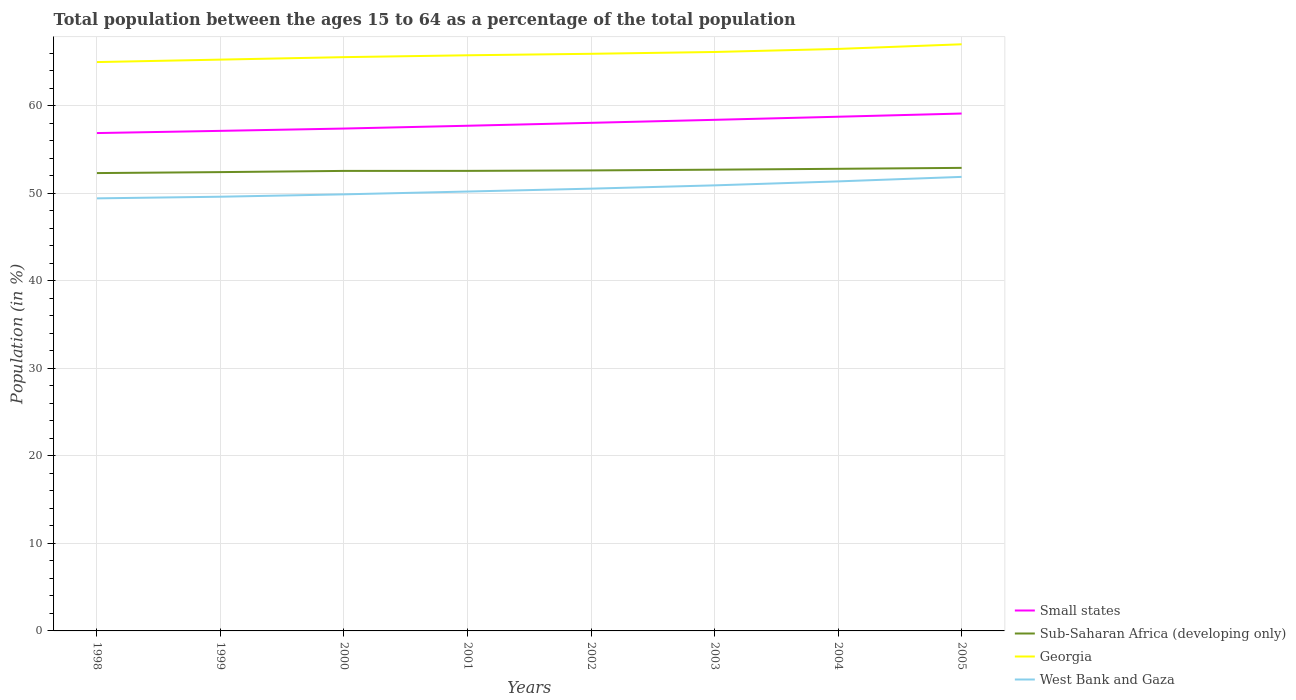Does the line corresponding to West Bank and Gaza intersect with the line corresponding to Small states?
Offer a terse response. No. Is the number of lines equal to the number of legend labels?
Keep it short and to the point. Yes. Across all years, what is the maximum percentage of the population ages 15 to 64 in Sub-Saharan Africa (developing only)?
Offer a very short reply. 52.33. In which year was the percentage of the population ages 15 to 64 in West Bank and Gaza maximum?
Offer a terse response. 1998. What is the total percentage of the population ages 15 to 64 in Georgia in the graph?
Ensure brevity in your answer.  -0.53. What is the difference between the highest and the second highest percentage of the population ages 15 to 64 in West Bank and Gaza?
Give a very brief answer. 2.46. What is the difference between the highest and the lowest percentage of the population ages 15 to 64 in Small states?
Provide a short and direct response. 4. Is the percentage of the population ages 15 to 64 in Georgia strictly greater than the percentage of the population ages 15 to 64 in Small states over the years?
Your response must be concise. No. What is the difference between two consecutive major ticks on the Y-axis?
Provide a succinct answer. 10. Are the values on the major ticks of Y-axis written in scientific E-notation?
Offer a very short reply. No. Does the graph contain any zero values?
Offer a terse response. No. Where does the legend appear in the graph?
Give a very brief answer. Bottom right. How are the legend labels stacked?
Your answer should be compact. Vertical. What is the title of the graph?
Keep it short and to the point. Total population between the ages 15 to 64 as a percentage of the total population. Does "Paraguay" appear as one of the legend labels in the graph?
Provide a succinct answer. No. What is the Population (in %) in Small states in 1998?
Provide a succinct answer. 56.9. What is the Population (in %) in Sub-Saharan Africa (developing only) in 1998?
Your answer should be very brief. 52.33. What is the Population (in %) in Georgia in 1998?
Make the answer very short. 65.01. What is the Population (in %) of West Bank and Gaza in 1998?
Your response must be concise. 49.44. What is the Population (in %) of Small states in 1999?
Keep it short and to the point. 57.15. What is the Population (in %) in Sub-Saharan Africa (developing only) in 1999?
Your answer should be very brief. 52.44. What is the Population (in %) of Georgia in 1999?
Your answer should be very brief. 65.3. What is the Population (in %) of West Bank and Gaza in 1999?
Provide a short and direct response. 49.63. What is the Population (in %) of Small states in 2000?
Give a very brief answer. 57.42. What is the Population (in %) of Sub-Saharan Africa (developing only) in 2000?
Your answer should be compact. 52.58. What is the Population (in %) in Georgia in 2000?
Offer a very short reply. 65.58. What is the Population (in %) of West Bank and Gaza in 2000?
Offer a very short reply. 49.9. What is the Population (in %) in Small states in 2001?
Your answer should be very brief. 57.74. What is the Population (in %) of Sub-Saharan Africa (developing only) in 2001?
Your answer should be very brief. 52.58. What is the Population (in %) of Georgia in 2001?
Keep it short and to the point. 65.79. What is the Population (in %) in West Bank and Gaza in 2001?
Provide a short and direct response. 50.22. What is the Population (in %) of Small states in 2002?
Your answer should be compact. 58.07. What is the Population (in %) of Sub-Saharan Africa (developing only) in 2002?
Offer a very short reply. 52.63. What is the Population (in %) of Georgia in 2002?
Make the answer very short. 65.96. What is the Population (in %) of West Bank and Gaza in 2002?
Ensure brevity in your answer.  50.55. What is the Population (in %) of Small states in 2003?
Provide a short and direct response. 58.42. What is the Population (in %) of Sub-Saharan Africa (developing only) in 2003?
Your answer should be compact. 52.72. What is the Population (in %) in Georgia in 2003?
Your answer should be compact. 66.17. What is the Population (in %) of West Bank and Gaza in 2003?
Keep it short and to the point. 50.93. What is the Population (in %) of Small states in 2004?
Provide a succinct answer. 58.77. What is the Population (in %) of Sub-Saharan Africa (developing only) in 2004?
Give a very brief answer. 52.82. What is the Population (in %) of Georgia in 2004?
Offer a terse response. 66.52. What is the Population (in %) of West Bank and Gaza in 2004?
Your answer should be very brief. 51.38. What is the Population (in %) in Small states in 2005?
Keep it short and to the point. 59.13. What is the Population (in %) in Sub-Saharan Africa (developing only) in 2005?
Provide a succinct answer. 52.92. What is the Population (in %) in Georgia in 2005?
Your answer should be compact. 67.05. What is the Population (in %) of West Bank and Gaza in 2005?
Provide a succinct answer. 51.89. Across all years, what is the maximum Population (in %) of Small states?
Ensure brevity in your answer.  59.13. Across all years, what is the maximum Population (in %) of Sub-Saharan Africa (developing only)?
Your answer should be compact. 52.92. Across all years, what is the maximum Population (in %) of Georgia?
Offer a very short reply. 67.05. Across all years, what is the maximum Population (in %) in West Bank and Gaza?
Your answer should be very brief. 51.89. Across all years, what is the minimum Population (in %) in Small states?
Ensure brevity in your answer.  56.9. Across all years, what is the minimum Population (in %) in Sub-Saharan Africa (developing only)?
Provide a succinct answer. 52.33. Across all years, what is the minimum Population (in %) of Georgia?
Offer a terse response. 65.01. Across all years, what is the minimum Population (in %) in West Bank and Gaza?
Your response must be concise. 49.44. What is the total Population (in %) in Small states in the graph?
Make the answer very short. 463.6. What is the total Population (in %) of Sub-Saharan Africa (developing only) in the graph?
Your response must be concise. 421.02. What is the total Population (in %) of Georgia in the graph?
Provide a short and direct response. 527.38. What is the total Population (in %) in West Bank and Gaza in the graph?
Give a very brief answer. 403.93. What is the difference between the Population (in %) of Small states in 1998 and that in 1999?
Give a very brief answer. -0.25. What is the difference between the Population (in %) of Sub-Saharan Africa (developing only) in 1998 and that in 1999?
Make the answer very short. -0.11. What is the difference between the Population (in %) of Georgia in 1998 and that in 1999?
Your answer should be compact. -0.28. What is the difference between the Population (in %) of West Bank and Gaza in 1998 and that in 1999?
Offer a terse response. -0.19. What is the difference between the Population (in %) of Small states in 1998 and that in 2000?
Ensure brevity in your answer.  -0.52. What is the difference between the Population (in %) of Sub-Saharan Africa (developing only) in 1998 and that in 2000?
Your answer should be very brief. -0.25. What is the difference between the Population (in %) in Georgia in 1998 and that in 2000?
Provide a succinct answer. -0.57. What is the difference between the Population (in %) in West Bank and Gaza in 1998 and that in 2000?
Give a very brief answer. -0.46. What is the difference between the Population (in %) of Small states in 1998 and that in 2001?
Offer a terse response. -0.84. What is the difference between the Population (in %) of Sub-Saharan Africa (developing only) in 1998 and that in 2001?
Make the answer very short. -0.25. What is the difference between the Population (in %) in Georgia in 1998 and that in 2001?
Give a very brief answer. -0.78. What is the difference between the Population (in %) of West Bank and Gaza in 1998 and that in 2001?
Provide a succinct answer. -0.78. What is the difference between the Population (in %) in Small states in 1998 and that in 2002?
Ensure brevity in your answer.  -1.17. What is the difference between the Population (in %) in Sub-Saharan Africa (developing only) in 1998 and that in 2002?
Provide a short and direct response. -0.3. What is the difference between the Population (in %) in Georgia in 1998 and that in 2002?
Your response must be concise. -0.95. What is the difference between the Population (in %) of West Bank and Gaza in 1998 and that in 2002?
Give a very brief answer. -1.11. What is the difference between the Population (in %) in Small states in 1998 and that in 2003?
Make the answer very short. -1.51. What is the difference between the Population (in %) in Sub-Saharan Africa (developing only) in 1998 and that in 2003?
Your answer should be compact. -0.39. What is the difference between the Population (in %) in Georgia in 1998 and that in 2003?
Your answer should be compact. -1.15. What is the difference between the Population (in %) in West Bank and Gaza in 1998 and that in 2003?
Your answer should be compact. -1.49. What is the difference between the Population (in %) of Small states in 1998 and that in 2004?
Provide a succinct answer. -1.87. What is the difference between the Population (in %) of Sub-Saharan Africa (developing only) in 1998 and that in 2004?
Keep it short and to the point. -0.49. What is the difference between the Population (in %) of Georgia in 1998 and that in 2004?
Your answer should be compact. -1.5. What is the difference between the Population (in %) of West Bank and Gaza in 1998 and that in 2004?
Keep it short and to the point. -1.94. What is the difference between the Population (in %) of Small states in 1998 and that in 2005?
Your response must be concise. -2.23. What is the difference between the Population (in %) of Sub-Saharan Africa (developing only) in 1998 and that in 2005?
Provide a short and direct response. -0.59. What is the difference between the Population (in %) of Georgia in 1998 and that in 2005?
Your response must be concise. -2.04. What is the difference between the Population (in %) in West Bank and Gaza in 1998 and that in 2005?
Your response must be concise. -2.46. What is the difference between the Population (in %) of Small states in 1999 and that in 2000?
Offer a terse response. -0.26. What is the difference between the Population (in %) of Sub-Saharan Africa (developing only) in 1999 and that in 2000?
Your answer should be compact. -0.14. What is the difference between the Population (in %) of Georgia in 1999 and that in 2000?
Provide a short and direct response. -0.28. What is the difference between the Population (in %) in West Bank and Gaza in 1999 and that in 2000?
Offer a very short reply. -0.27. What is the difference between the Population (in %) of Small states in 1999 and that in 2001?
Offer a very short reply. -0.59. What is the difference between the Population (in %) in Sub-Saharan Africa (developing only) in 1999 and that in 2001?
Make the answer very short. -0.14. What is the difference between the Population (in %) of Georgia in 1999 and that in 2001?
Your answer should be very brief. -0.49. What is the difference between the Population (in %) in West Bank and Gaza in 1999 and that in 2001?
Offer a very short reply. -0.59. What is the difference between the Population (in %) in Small states in 1999 and that in 2002?
Your answer should be compact. -0.92. What is the difference between the Population (in %) in Sub-Saharan Africa (developing only) in 1999 and that in 2002?
Offer a terse response. -0.19. What is the difference between the Population (in %) in Georgia in 1999 and that in 2002?
Keep it short and to the point. -0.66. What is the difference between the Population (in %) of West Bank and Gaza in 1999 and that in 2002?
Keep it short and to the point. -0.92. What is the difference between the Population (in %) of Small states in 1999 and that in 2003?
Keep it short and to the point. -1.26. What is the difference between the Population (in %) in Sub-Saharan Africa (developing only) in 1999 and that in 2003?
Your answer should be very brief. -0.28. What is the difference between the Population (in %) of Georgia in 1999 and that in 2003?
Give a very brief answer. -0.87. What is the difference between the Population (in %) of West Bank and Gaza in 1999 and that in 2003?
Keep it short and to the point. -1.3. What is the difference between the Population (in %) in Small states in 1999 and that in 2004?
Your response must be concise. -1.61. What is the difference between the Population (in %) of Sub-Saharan Africa (developing only) in 1999 and that in 2004?
Your response must be concise. -0.38. What is the difference between the Population (in %) in Georgia in 1999 and that in 2004?
Your answer should be very brief. -1.22. What is the difference between the Population (in %) of West Bank and Gaza in 1999 and that in 2004?
Give a very brief answer. -1.75. What is the difference between the Population (in %) of Small states in 1999 and that in 2005?
Make the answer very short. -1.98. What is the difference between the Population (in %) of Sub-Saharan Africa (developing only) in 1999 and that in 2005?
Provide a succinct answer. -0.48. What is the difference between the Population (in %) in Georgia in 1999 and that in 2005?
Keep it short and to the point. -1.75. What is the difference between the Population (in %) in West Bank and Gaza in 1999 and that in 2005?
Offer a terse response. -2.27. What is the difference between the Population (in %) of Small states in 2000 and that in 2001?
Keep it short and to the point. -0.32. What is the difference between the Population (in %) in Sub-Saharan Africa (developing only) in 2000 and that in 2001?
Provide a short and direct response. -0. What is the difference between the Population (in %) of Georgia in 2000 and that in 2001?
Offer a terse response. -0.21. What is the difference between the Population (in %) in West Bank and Gaza in 2000 and that in 2001?
Provide a short and direct response. -0.32. What is the difference between the Population (in %) in Small states in 2000 and that in 2002?
Provide a short and direct response. -0.65. What is the difference between the Population (in %) in Sub-Saharan Africa (developing only) in 2000 and that in 2002?
Your response must be concise. -0.06. What is the difference between the Population (in %) of Georgia in 2000 and that in 2002?
Your answer should be compact. -0.38. What is the difference between the Population (in %) in West Bank and Gaza in 2000 and that in 2002?
Give a very brief answer. -0.65. What is the difference between the Population (in %) in Small states in 2000 and that in 2003?
Your answer should be compact. -1. What is the difference between the Population (in %) in Sub-Saharan Africa (developing only) in 2000 and that in 2003?
Offer a very short reply. -0.14. What is the difference between the Population (in %) in Georgia in 2000 and that in 2003?
Your answer should be very brief. -0.59. What is the difference between the Population (in %) in West Bank and Gaza in 2000 and that in 2003?
Offer a very short reply. -1.03. What is the difference between the Population (in %) in Small states in 2000 and that in 2004?
Your answer should be compact. -1.35. What is the difference between the Population (in %) in Sub-Saharan Africa (developing only) in 2000 and that in 2004?
Your answer should be very brief. -0.24. What is the difference between the Population (in %) of Georgia in 2000 and that in 2004?
Offer a terse response. -0.94. What is the difference between the Population (in %) in West Bank and Gaza in 2000 and that in 2004?
Offer a very short reply. -1.48. What is the difference between the Population (in %) of Small states in 2000 and that in 2005?
Provide a short and direct response. -1.72. What is the difference between the Population (in %) of Sub-Saharan Africa (developing only) in 2000 and that in 2005?
Ensure brevity in your answer.  -0.35. What is the difference between the Population (in %) in Georgia in 2000 and that in 2005?
Give a very brief answer. -1.47. What is the difference between the Population (in %) in West Bank and Gaza in 2000 and that in 2005?
Offer a terse response. -2. What is the difference between the Population (in %) in Small states in 2001 and that in 2002?
Your answer should be compact. -0.33. What is the difference between the Population (in %) of Sub-Saharan Africa (developing only) in 2001 and that in 2002?
Your answer should be compact. -0.05. What is the difference between the Population (in %) of Georgia in 2001 and that in 2002?
Offer a very short reply. -0.17. What is the difference between the Population (in %) of West Bank and Gaza in 2001 and that in 2002?
Make the answer very short. -0.33. What is the difference between the Population (in %) of Small states in 2001 and that in 2003?
Offer a very short reply. -0.68. What is the difference between the Population (in %) of Sub-Saharan Africa (developing only) in 2001 and that in 2003?
Your response must be concise. -0.14. What is the difference between the Population (in %) in Georgia in 2001 and that in 2003?
Offer a very short reply. -0.38. What is the difference between the Population (in %) of West Bank and Gaza in 2001 and that in 2003?
Keep it short and to the point. -0.71. What is the difference between the Population (in %) of Small states in 2001 and that in 2004?
Provide a succinct answer. -1.03. What is the difference between the Population (in %) of Sub-Saharan Africa (developing only) in 2001 and that in 2004?
Offer a terse response. -0.24. What is the difference between the Population (in %) in Georgia in 2001 and that in 2004?
Provide a short and direct response. -0.73. What is the difference between the Population (in %) in West Bank and Gaza in 2001 and that in 2004?
Provide a short and direct response. -1.16. What is the difference between the Population (in %) of Small states in 2001 and that in 2005?
Ensure brevity in your answer.  -1.4. What is the difference between the Population (in %) of Sub-Saharan Africa (developing only) in 2001 and that in 2005?
Keep it short and to the point. -0.34. What is the difference between the Population (in %) in Georgia in 2001 and that in 2005?
Keep it short and to the point. -1.26. What is the difference between the Population (in %) of West Bank and Gaza in 2001 and that in 2005?
Offer a very short reply. -1.67. What is the difference between the Population (in %) in Small states in 2002 and that in 2003?
Give a very brief answer. -0.34. What is the difference between the Population (in %) of Sub-Saharan Africa (developing only) in 2002 and that in 2003?
Your answer should be very brief. -0.08. What is the difference between the Population (in %) in Georgia in 2002 and that in 2003?
Keep it short and to the point. -0.21. What is the difference between the Population (in %) in West Bank and Gaza in 2002 and that in 2003?
Provide a short and direct response. -0.38. What is the difference between the Population (in %) of Small states in 2002 and that in 2004?
Provide a short and direct response. -0.7. What is the difference between the Population (in %) of Sub-Saharan Africa (developing only) in 2002 and that in 2004?
Your response must be concise. -0.18. What is the difference between the Population (in %) in Georgia in 2002 and that in 2004?
Your answer should be compact. -0.56. What is the difference between the Population (in %) in West Bank and Gaza in 2002 and that in 2004?
Keep it short and to the point. -0.83. What is the difference between the Population (in %) of Small states in 2002 and that in 2005?
Provide a succinct answer. -1.06. What is the difference between the Population (in %) of Sub-Saharan Africa (developing only) in 2002 and that in 2005?
Keep it short and to the point. -0.29. What is the difference between the Population (in %) of Georgia in 2002 and that in 2005?
Your answer should be compact. -1.09. What is the difference between the Population (in %) of West Bank and Gaza in 2002 and that in 2005?
Give a very brief answer. -1.35. What is the difference between the Population (in %) of Small states in 2003 and that in 2004?
Ensure brevity in your answer.  -0.35. What is the difference between the Population (in %) in Sub-Saharan Africa (developing only) in 2003 and that in 2004?
Your answer should be compact. -0.1. What is the difference between the Population (in %) of Georgia in 2003 and that in 2004?
Offer a terse response. -0.35. What is the difference between the Population (in %) of West Bank and Gaza in 2003 and that in 2004?
Your response must be concise. -0.45. What is the difference between the Population (in %) in Small states in 2003 and that in 2005?
Provide a succinct answer. -0.72. What is the difference between the Population (in %) of Sub-Saharan Africa (developing only) in 2003 and that in 2005?
Keep it short and to the point. -0.21. What is the difference between the Population (in %) in Georgia in 2003 and that in 2005?
Ensure brevity in your answer.  -0.88. What is the difference between the Population (in %) of West Bank and Gaza in 2003 and that in 2005?
Give a very brief answer. -0.97. What is the difference between the Population (in %) in Small states in 2004 and that in 2005?
Your answer should be compact. -0.37. What is the difference between the Population (in %) in Sub-Saharan Africa (developing only) in 2004 and that in 2005?
Give a very brief answer. -0.11. What is the difference between the Population (in %) in Georgia in 2004 and that in 2005?
Offer a terse response. -0.53. What is the difference between the Population (in %) of West Bank and Gaza in 2004 and that in 2005?
Your response must be concise. -0.52. What is the difference between the Population (in %) in Small states in 1998 and the Population (in %) in Sub-Saharan Africa (developing only) in 1999?
Provide a short and direct response. 4.46. What is the difference between the Population (in %) in Small states in 1998 and the Population (in %) in Georgia in 1999?
Give a very brief answer. -8.4. What is the difference between the Population (in %) in Small states in 1998 and the Population (in %) in West Bank and Gaza in 1999?
Give a very brief answer. 7.27. What is the difference between the Population (in %) in Sub-Saharan Africa (developing only) in 1998 and the Population (in %) in Georgia in 1999?
Give a very brief answer. -12.97. What is the difference between the Population (in %) in Sub-Saharan Africa (developing only) in 1998 and the Population (in %) in West Bank and Gaza in 1999?
Provide a succinct answer. 2.7. What is the difference between the Population (in %) in Georgia in 1998 and the Population (in %) in West Bank and Gaza in 1999?
Provide a succinct answer. 15.39. What is the difference between the Population (in %) in Small states in 1998 and the Population (in %) in Sub-Saharan Africa (developing only) in 2000?
Provide a short and direct response. 4.32. What is the difference between the Population (in %) in Small states in 1998 and the Population (in %) in Georgia in 2000?
Your response must be concise. -8.68. What is the difference between the Population (in %) of Small states in 1998 and the Population (in %) of West Bank and Gaza in 2000?
Provide a short and direct response. 7. What is the difference between the Population (in %) of Sub-Saharan Africa (developing only) in 1998 and the Population (in %) of Georgia in 2000?
Your response must be concise. -13.25. What is the difference between the Population (in %) of Sub-Saharan Africa (developing only) in 1998 and the Population (in %) of West Bank and Gaza in 2000?
Your answer should be compact. 2.43. What is the difference between the Population (in %) of Georgia in 1998 and the Population (in %) of West Bank and Gaza in 2000?
Your answer should be very brief. 15.12. What is the difference between the Population (in %) in Small states in 1998 and the Population (in %) in Sub-Saharan Africa (developing only) in 2001?
Ensure brevity in your answer.  4.32. What is the difference between the Population (in %) of Small states in 1998 and the Population (in %) of Georgia in 2001?
Offer a terse response. -8.89. What is the difference between the Population (in %) in Small states in 1998 and the Population (in %) in West Bank and Gaza in 2001?
Make the answer very short. 6.68. What is the difference between the Population (in %) of Sub-Saharan Africa (developing only) in 1998 and the Population (in %) of Georgia in 2001?
Offer a very short reply. -13.46. What is the difference between the Population (in %) in Sub-Saharan Africa (developing only) in 1998 and the Population (in %) in West Bank and Gaza in 2001?
Your answer should be very brief. 2.11. What is the difference between the Population (in %) in Georgia in 1998 and the Population (in %) in West Bank and Gaza in 2001?
Give a very brief answer. 14.79. What is the difference between the Population (in %) of Small states in 1998 and the Population (in %) of Sub-Saharan Africa (developing only) in 2002?
Keep it short and to the point. 4.27. What is the difference between the Population (in %) in Small states in 1998 and the Population (in %) in Georgia in 2002?
Provide a succinct answer. -9.06. What is the difference between the Population (in %) of Small states in 1998 and the Population (in %) of West Bank and Gaza in 2002?
Offer a very short reply. 6.35. What is the difference between the Population (in %) in Sub-Saharan Africa (developing only) in 1998 and the Population (in %) in Georgia in 2002?
Provide a short and direct response. -13.63. What is the difference between the Population (in %) of Sub-Saharan Africa (developing only) in 1998 and the Population (in %) of West Bank and Gaza in 2002?
Make the answer very short. 1.78. What is the difference between the Population (in %) of Georgia in 1998 and the Population (in %) of West Bank and Gaza in 2002?
Offer a terse response. 14.47. What is the difference between the Population (in %) of Small states in 1998 and the Population (in %) of Sub-Saharan Africa (developing only) in 2003?
Your answer should be very brief. 4.18. What is the difference between the Population (in %) of Small states in 1998 and the Population (in %) of Georgia in 2003?
Offer a terse response. -9.27. What is the difference between the Population (in %) in Small states in 1998 and the Population (in %) in West Bank and Gaza in 2003?
Offer a terse response. 5.98. What is the difference between the Population (in %) of Sub-Saharan Africa (developing only) in 1998 and the Population (in %) of Georgia in 2003?
Your answer should be very brief. -13.84. What is the difference between the Population (in %) in Sub-Saharan Africa (developing only) in 1998 and the Population (in %) in West Bank and Gaza in 2003?
Offer a terse response. 1.4. What is the difference between the Population (in %) of Georgia in 1998 and the Population (in %) of West Bank and Gaza in 2003?
Give a very brief answer. 14.09. What is the difference between the Population (in %) of Small states in 1998 and the Population (in %) of Sub-Saharan Africa (developing only) in 2004?
Keep it short and to the point. 4.08. What is the difference between the Population (in %) in Small states in 1998 and the Population (in %) in Georgia in 2004?
Offer a terse response. -9.62. What is the difference between the Population (in %) of Small states in 1998 and the Population (in %) of West Bank and Gaza in 2004?
Give a very brief answer. 5.52. What is the difference between the Population (in %) in Sub-Saharan Africa (developing only) in 1998 and the Population (in %) in Georgia in 2004?
Offer a terse response. -14.19. What is the difference between the Population (in %) of Sub-Saharan Africa (developing only) in 1998 and the Population (in %) of West Bank and Gaza in 2004?
Offer a terse response. 0.95. What is the difference between the Population (in %) of Georgia in 1998 and the Population (in %) of West Bank and Gaza in 2004?
Make the answer very short. 13.64. What is the difference between the Population (in %) in Small states in 1998 and the Population (in %) in Sub-Saharan Africa (developing only) in 2005?
Provide a succinct answer. 3.98. What is the difference between the Population (in %) in Small states in 1998 and the Population (in %) in Georgia in 2005?
Provide a short and direct response. -10.15. What is the difference between the Population (in %) in Small states in 1998 and the Population (in %) in West Bank and Gaza in 2005?
Offer a terse response. 5.01. What is the difference between the Population (in %) of Sub-Saharan Africa (developing only) in 1998 and the Population (in %) of Georgia in 2005?
Your response must be concise. -14.72. What is the difference between the Population (in %) of Sub-Saharan Africa (developing only) in 1998 and the Population (in %) of West Bank and Gaza in 2005?
Your answer should be compact. 0.44. What is the difference between the Population (in %) in Georgia in 1998 and the Population (in %) in West Bank and Gaza in 2005?
Your answer should be compact. 13.12. What is the difference between the Population (in %) of Small states in 1999 and the Population (in %) of Sub-Saharan Africa (developing only) in 2000?
Your answer should be very brief. 4.58. What is the difference between the Population (in %) of Small states in 1999 and the Population (in %) of Georgia in 2000?
Your answer should be very brief. -8.43. What is the difference between the Population (in %) in Small states in 1999 and the Population (in %) in West Bank and Gaza in 2000?
Your response must be concise. 7.26. What is the difference between the Population (in %) of Sub-Saharan Africa (developing only) in 1999 and the Population (in %) of Georgia in 2000?
Keep it short and to the point. -13.14. What is the difference between the Population (in %) in Sub-Saharan Africa (developing only) in 1999 and the Population (in %) in West Bank and Gaza in 2000?
Make the answer very short. 2.54. What is the difference between the Population (in %) in Georgia in 1999 and the Population (in %) in West Bank and Gaza in 2000?
Give a very brief answer. 15.4. What is the difference between the Population (in %) in Small states in 1999 and the Population (in %) in Sub-Saharan Africa (developing only) in 2001?
Provide a short and direct response. 4.57. What is the difference between the Population (in %) in Small states in 1999 and the Population (in %) in Georgia in 2001?
Provide a succinct answer. -8.64. What is the difference between the Population (in %) of Small states in 1999 and the Population (in %) of West Bank and Gaza in 2001?
Ensure brevity in your answer.  6.93. What is the difference between the Population (in %) of Sub-Saharan Africa (developing only) in 1999 and the Population (in %) of Georgia in 2001?
Your answer should be compact. -13.35. What is the difference between the Population (in %) of Sub-Saharan Africa (developing only) in 1999 and the Population (in %) of West Bank and Gaza in 2001?
Your answer should be very brief. 2.22. What is the difference between the Population (in %) in Georgia in 1999 and the Population (in %) in West Bank and Gaza in 2001?
Keep it short and to the point. 15.08. What is the difference between the Population (in %) of Small states in 1999 and the Population (in %) of Sub-Saharan Africa (developing only) in 2002?
Provide a succinct answer. 4.52. What is the difference between the Population (in %) of Small states in 1999 and the Population (in %) of Georgia in 2002?
Your response must be concise. -8.81. What is the difference between the Population (in %) in Small states in 1999 and the Population (in %) in West Bank and Gaza in 2002?
Keep it short and to the point. 6.6. What is the difference between the Population (in %) of Sub-Saharan Africa (developing only) in 1999 and the Population (in %) of Georgia in 2002?
Keep it short and to the point. -13.52. What is the difference between the Population (in %) in Sub-Saharan Africa (developing only) in 1999 and the Population (in %) in West Bank and Gaza in 2002?
Offer a very short reply. 1.89. What is the difference between the Population (in %) in Georgia in 1999 and the Population (in %) in West Bank and Gaza in 2002?
Offer a terse response. 14.75. What is the difference between the Population (in %) in Small states in 1999 and the Population (in %) in Sub-Saharan Africa (developing only) in 2003?
Your answer should be compact. 4.44. What is the difference between the Population (in %) in Small states in 1999 and the Population (in %) in Georgia in 2003?
Provide a short and direct response. -9.02. What is the difference between the Population (in %) of Small states in 1999 and the Population (in %) of West Bank and Gaza in 2003?
Give a very brief answer. 6.23. What is the difference between the Population (in %) of Sub-Saharan Africa (developing only) in 1999 and the Population (in %) of Georgia in 2003?
Provide a short and direct response. -13.73. What is the difference between the Population (in %) in Sub-Saharan Africa (developing only) in 1999 and the Population (in %) in West Bank and Gaza in 2003?
Offer a terse response. 1.51. What is the difference between the Population (in %) of Georgia in 1999 and the Population (in %) of West Bank and Gaza in 2003?
Your answer should be compact. 14.37. What is the difference between the Population (in %) of Small states in 1999 and the Population (in %) of Sub-Saharan Africa (developing only) in 2004?
Your answer should be very brief. 4.34. What is the difference between the Population (in %) of Small states in 1999 and the Population (in %) of Georgia in 2004?
Your response must be concise. -9.37. What is the difference between the Population (in %) in Small states in 1999 and the Population (in %) in West Bank and Gaza in 2004?
Offer a terse response. 5.77. What is the difference between the Population (in %) in Sub-Saharan Africa (developing only) in 1999 and the Population (in %) in Georgia in 2004?
Keep it short and to the point. -14.08. What is the difference between the Population (in %) in Sub-Saharan Africa (developing only) in 1999 and the Population (in %) in West Bank and Gaza in 2004?
Offer a very short reply. 1.06. What is the difference between the Population (in %) of Georgia in 1999 and the Population (in %) of West Bank and Gaza in 2004?
Keep it short and to the point. 13.92. What is the difference between the Population (in %) in Small states in 1999 and the Population (in %) in Sub-Saharan Africa (developing only) in 2005?
Offer a terse response. 4.23. What is the difference between the Population (in %) of Small states in 1999 and the Population (in %) of Georgia in 2005?
Give a very brief answer. -9.9. What is the difference between the Population (in %) in Small states in 1999 and the Population (in %) in West Bank and Gaza in 2005?
Your answer should be very brief. 5.26. What is the difference between the Population (in %) of Sub-Saharan Africa (developing only) in 1999 and the Population (in %) of Georgia in 2005?
Your answer should be very brief. -14.61. What is the difference between the Population (in %) in Sub-Saharan Africa (developing only) in 1999 and the Population (in %) in West Bank and Gaza in 2005?
Your answer should be very brief. 0.55. What is the difference between the Population (in %) of Georgia in 1999 and the Population (in %) of West Bank and Gaza in 2005?
Keep it short and to the point. 13.4. What is the difference between the Population (in %) in Small states in 2000 and the Population (in %) in Sub-Saharan Africa (developing only) in 2001?
Provide a succinct answer. 4.84. What is the difference between the Population (in %) in Small states in 2000 and the Population (in %) in Georgia in 2001?
Give a very brief answer. -8.37. What is the difference between the Population (in %) in Small states in 2000 and the Population (in %) in West Bank and Gaza in 2001?
Give a very brief answer. 7.2. What is the difference between the Population (in %) of Sub-Saharan Africa (developing only) in 2000 and the Population (in %) of Georgia in 2001?
Provide a succinct answer. -13.21. What is the difference between the Population (in %) of Sub-Saharan Africa (developing only) in 2000 and the Population (in %) of West Bank and Gaza in 2001?
Your answer should be very brief. 2.36. What is the difference between the Population (in %) of Georgia in 2000 and the Population (in %) of West Bank and Gaza in 2001?
Ensure brevity in your answer.  15.36. What is the difference between the Population (in %) in Small states in 2000 and the Population (in %) in Sub-Saharan Africa (developing only) in 2002?
Provide a short and direct response. 4.79. What is the difference between the Population (in %) of Small states in 2000 and the Population (in %) of Georgia in 2002?
Offer a terse response. -8.54. What is the difference between the Population (in %) in Small states in 2000 and the Population (in %) in West Bank and Gaza in 2002?
Make the answer very short. 6.87. What is the difference between the Population (in %) of Sub-Saharan Africa (developing only) in 2000 and the Population (in %) of Georgia in 2002?
Your answer should be very brief. -13.38. What is the difference between the Population (in %) in Sub-Saharan Africa (developing only) in 2000 and the Population (in %) in West Bank and Gaza in 2002?
Offer a terse response. 2.03. What is the difference between the Population (in %) of Georgia in 2000 and the Population (in %) of West Bank and Gaza in 2002?
Keep it short and to the point. 15.03. What is the difference between the Population (in %) of Small states in 2000 and the Population (in %) of Sub-Saharan Africa (developing only) in 2003?
Provide a succinct answer. 4.7. What is the difference between the Population (in %) in Small states in 2000 and the Population (in %) in Georgia in 2003?
Your answer should be compact. -8.75. What is the difference between the Population (in %) in Small states in 2000 and the Population (in %) in West Bank and Gaza in 2003?
Ensure brevity in your answer.  6.49. What is the difference between the Population (in %) of Sub-Saharan Africa (developing only) in 2000 and the Population (in %) of Georgia in 2003?
Provide a succinct answer. -13.59. What is the difference between the Population (in %) of Sub-Saharan Africa (developing only) in 2000 and the Population (in %) of West Bank and Gaza in 2003?
Ensure brevity in your answer.  1.65. What is the difference between the Population (in %) in Georgia in 2000 and the Population (in %) in West Bank and Gaza in 2003?
Offer a very short reply. 14.65. What is the difference between the Population (in %) in Small states in 2000 and the Population (in %) in Sub-Saharan Africa (developing only) in 2004?
Give a very brief answer. 4.6. What is the difference between the Population (in %) of Small states in 2000 and the Population (in %) of Georgia in 2004?
Make the answer very short. -9.1. What is the difference between the Population (in %) in Small states in 2000 and the Population (in %) in West Bank and Gaza in 2004?
Offer a terse response. 6.04. What is the difference between the Population (in %) in Sub-Saharan Africa (developing only) in 2000 and the Population (in %) in Georgia in 2004?
Make the answer very short. -13.94. What is the difference between the Population (in %) in Sub-Saharan Africa (developing only) in 2000 and the Population (in %) in West Bank and Gaza in 2004?
Ensure brevity in your answer.  1.2. What is the difference between the Population (in %) in Georgia in 2000 and the Population (in %) in West Bank and Gaza in 2004?
Make the answer very short. 14.2. What is the difference between the Population (in %) in Small states in 2000 and the Population (in %) in Sub-Saharan Africa (developing only) in 2005?
Your answer should be very brief. 4.49. What is the difference between the Population (in %) of Small states in 2000 and the Population (in %) of Georgia in 2005?
Offer a very short reply. -9.63. What is the difference between the Population (in %) of Small states in 2000 and the Population (in %) of West Bank and Gaza in 2005?
Give a very brief answer. 5.52. What is the difference between the Population (in %) in Sub-Saharan Africa (developing only) in 2000 and the Population (in %) in Georgia in 2005?
Ensure brevity in your answer.  -14.47. What is the difference between the Population (in %) of Sub-Saharan Africa (developing only) in 2000 and the Population (in %) of West Bank and Gaza in 2005?
Your answer should be compact. 0.68. What is the difference between the Population (in %) in Georgia in 2000 and the Population (in %) in West Bank and Gaza in 2005?
Provide a succinct answer. 13.69. What is the difference between the Population (in %) in Small states in 2001 and the Population (in %) in Sub-Saharan Africa (developing only) in 2002?
Make the answer very short. 5.11. What is the difference between the Population (in %) of Small states in 2001 and the Population (in %) of Georgia in 2002?
Your answer should be very brief. -8.22. What is the difference between the Population (in %) in Small states in 2001 and the Population (in %) in West Bank and Gaza in 2002?
Ensure brevity in your answer.  7.19. What is the difference between the Population (in %) in Sub-Saharan Africa (developing only) in 2001 and the Population (in %) in Georgia in 2002?
Make the answer very short. -13.38. What is the difference between the Population (in %) of Sub-Saharan Africa (developing only) in 2001 and the Population (in %) of West Bank and Gaza in 2002?
Offer a very short reply. 2.03. What is the difference between the Population (in %) of Georgia in 2001 and the Population (in %) of West Bank and Gaza in 2002?
Your answer should be very brief. 15.24. What is the difference between the Population (in %) in Small states in 2001 and the Population (in %) in Sub-Saharan Africa (developing only) in 2003?
Make the answer very short. 5.02. What is the difference between the Population (in %) in Small states in 2001 and the Population (in %) in Georgia in 2003?
Your answer should be very brief. -8.43. What is the difference between the Population (in %) in Small states in 2001 and the Population (in %) in West Bank and Gaza in 2003?
Offer a very short reply. 6.81. What is the difference between the Population (in %) in Sub-Saharan Africa (developing only) in 2001 and the Population (in %) in Georgia in 2003?
Make the answer very short. -13.59. What is the difference between the Population (in %) of Sub-Saharan Africa (developing only) in 2001 and the Population (in %) of West Bank and Gaza in 2003?
Offer a terse response. 1.66. What is the difference between the Population (in %) of Georgia in 2001 and the Population (in %) of West Bank and Gaza in 2003?
Offer a terse response. 14.87. What is the difference between the Population (in %) of Small states in 2001 and the Population (in %) of Sub-Saharan Africa (developing only) in 2004?
Provide a succinct answer. 4.92. What is the difference between the Population (in %) of Small states in 2001 and the Population (in %) of Georgia in 2004?
Provide a succinct answer. -8.78. What is the difference between the Population (in %) in Small states in 2001 and the Population (in %) in West Bank and Gaza in 2004?
Keep it short and to the point. 6.36. What is the difference between the Population (in %) in Sub-Saharan Africa (developing only) in 2001 and the Population (in %) in Georgia in 2004?
Give a very brief answer. -13.94. What is the difference between the Population (in %) of Sub-Saharan Africa (developing only) in 2001 and the Population (in %) of West Bank and Gaza in 2004?
Your response must be concise. 1.2. What is the difference between the Population (in %) of Georgia in 2001 and the Population (in %) of West Bank and Gaza in 2004?
Your answer should be very brief. 14.41. What is the difference between the Population (in %) of Small states in 2001 and the Population (in %) of Sub-Saharan Africa (developing only) in 2005?
Provide a short and direct response. 4.82. What is the difference between the Population (in %) of Small states in 2001 and the Population (in %) of Georgia in 2005?
Provide a short and direct response. -9.31. What is the difference between the Population (in %) of Small states in 2001 and the Population (in %) of West Bank and Gaza in 2005?
Your answer should be compact. 5.84. What is the difference between the Population (in %) in Sub-Saharan Africa (developing only) in 2001 and the Population (in %) in Georgia in 2005?
Ensure brevity in your answer.  -14.47. What is the difference between the Population (in %) of Sub-Saharan Africa (developing only) in 2001 and the Population (in %) of West Bank and Gaza in 2005?
Provide a short and direct response. 0.69. What is the difference between the Population (in %) in Georgia in 2001 and the Population (in %) in West Bank and Gaza in 2005?
Provide a succinct answer. 13.9. What is the difference between the Population (in %) of Small states in 2002 and the Population (in %) of Sub-Saharan Africa (developing only) in 2003?
Ensure brevity in your answer.  5.35. What is the difference between the Population (in %) in Small states in 2002 and the Population (in %) in Georgia in 2003?
Your answer should be very brief. -8.1. What is the difference between the Population (in %) of Small states in 2002 and the Population (in %) of West Bank and Gaza in 2003?
Make the answer very short. 7.15. What is the difference between the Population (in %) in Sub-Saharan Africa (developing only) in 2002 and the Population (in %) in Georgia in 2003?
Make the answer very short. -13.54. What is the difference between the Population (in %) in Sub-Saharan Africa (developing only) in 2002 and the Population (in %) in West Bank and Gaza in 2003?
Ensure brevity in your answer.  1.71. What is the difference between the Population (in %) of Georgia in 2002 and the Population (in %) of West Bank and Gaza in 2003?
Provide a succinct answer. 15.04. What is the difference between the Population (in %) in Small states in 2002 and the Population (in %) in Sub-Saharan Africa (developing only) in 2004?
Your answer should be compact. 5.25. What is the difference between the Population (in %) in Small states in 2002 and the Population (in %) in Georgia in 2004?
Give a very brief answer. -8.45. What is the difference between the Population (in %) in Small states in 2002 and the Population (in %) in West Bank and Gaza in 2004?
Your answer should be compact. 6.69. What is the difference between the Population (in %) in Sub-Saharan Africa (developing only) in 2002 and the Population (in %) in Georgia in 2004?
Keep it short and to the point. -13.89. What is the difference between the Population (in %) of Sub-Saharan Africa (developing only) in 2002 and the Population (in %) of West Bank and Gaza in 2004?
Offer a very short reply. 1.25. What is the difference between the Population (in %) in Georgia in 2002 and the Population (in %) in West Bank and Gaza in 2004?
Your answer should be very brief. 14.58. What is the difference between the Population (in %) in Small states in 2002 and the Population (in %) in Sub-Saharan Africa (developing only) in 2005?
Offer a terse response. 5.15. What is the difference between the Population (in %) of Small states in 2002 and the Population (in %) of Georgia in 2005?
Keep it short and to the point. -8.98. What is the difference between the Population (in %) in Small states in 2002 and the Population (in %) in West Bank and Gaza in 2005?
Ensure brevity in your answer.  6.18. What is the difference between the Population (in %) of Sub-Saharan Africa (developing only) in 2002 and the Population (in %) of Georgia in 2005?
Provide a succinct answer. -14.42. What is the difference between the Population (in %) of Sub-Saharan Africa (developing only) in 2002 and the Population (in %) of West Bank and Gaza in 2005?
Offer a very short reply. 0.74. What is the difference between the Population (in %) of Georgia in 2002 and the Population (in %) of West Bank and Gaza in 2005?
Keep it short and to the point. 14.07. What is the difference between the Population (in %) in Small states in 2003 and the Population (in %) in Sub-Saharan Africa (developing only) in 2004?
Your answer should be very brief. 5.6. What is the difference between the Population (in %) of Small states in 2003 and the Population (in %) of Georgia in 2004?
Offer a very short reply. -8.1. What is the difference between the Population (in %) in Small states in 2003 and the Population (in %) in West Bank and Gaza in 2004?
Your response must be concise. 7.04. What is the difference between the Population (in %) in Sub-Saharan Africa (developing only) in 2003 and the Population (in %) in Georgia in 2004?
Provide a succinct answer. -13.8. What is the difference between the Population (in %) in Sub-Saharan Africa (developing only) in 2003 and the Population (in %) in West Bank and Gaza in 2004?
Your response must be concise. 1.34. What is the difference between the Population (in %) in Georgia in 2003 and the Population (in %) in West Bank and Gaza in 2004?
Provide a succinct answer. 14.79. What is the difference between the Population (in %) of Small states in 2003 and the Population (in %) of Sub-Saharan Africa (developing only) in 2005?
Keep it short and to the point. 5.49. What is the difference between the Population (in %) of Small states in 2003 and the Population (in %) of Georgia in 2005?
Offer a very short reply. -8.63. What is the difference between the Population (in %) of Small states in 2003 and the Population (in %) of West Bank and Gaza in 2005?
Give a very brief answer. 6.52. What is the difference between the Population (in %) in Sub-Saharan Africa (developing only) in 2003 and the Population (in %) in Georgia in 2005?
Your answer should be very brief. -14.33. What is the difference between the Population (in %) in Sub-Saharan Africa (developing only) in 2003 and the Population (in %) in West Bank and Gaza in 2005?
Provide a short and direct response. 0.82. What is the difference between the Population (in %) in Georgia in 2003 and the Population (in %) in West Bank and Gaza in 2005?
Offer a terse response. 14.28. What is the difference between the Population (in %) of Small states in 2004 and the Population (in %) of Sub-Saharan Africa (developing only) in 2005?
Your answer should be compact. 5.85. What is the difference between the Population (in %) in Small states in 2004 and the Population (in %) in Georgia in 2005?
Provide a succinct answer. -8.28. What is the difference between the Population (in %) of Small states in 2004 and the Population (in %) of West Bank and Gaza in 2005?
Offer a terse response. 6.87. What is the difference between the Population (in %) in Sub-Saharan Africa (developing only) in 2004 and the Population (in %) in Georgia in 2005?
Keep it short and to the point. -14.23. What is the difference between the Population (in %) in Sub-Saharan Africa (developing only) in 2004 and the Population (in %) in West Bank and Gaza in 2005?
Give a very brief answer. 0.92. What is the difference between the Population (in %) in Georgia in 2004 and the Population (in %) in West Bank and Gaza in 2005?
Your answer should be compact. 14.62. What is the average Population (in %) in Small states per year?
Give a very brief answer. 57.95. What is the average Population (in %) of Sub-Saharan Africa (developing only) per year?
Give a very brief answer. 52.63. What is the average Population (in %) of Georgia per year?
Provide a short and direct response. 65.92. What is the average Population (in %) of West Bank and Gaza per year?
Give a very brief answer. 50.49. In the year 1998, what is the difference between the Population (in %) in Small states and Population (in %) in Sub-Saharan Africa (developing only)?
Make the answer very short. 4.57. In the year 1998, what is the difference between the Population (in %) in Small states and Population (in %) in Georgia?
Ensure brevity in your answer.  -8.11. In the year 1998, what is the difference between the Population (in %) in Small states and Population (in %) in West Bank and Gaza?
Your answer should be very brief. 7.46. In the year 1998, what is the difference between the Population (in %) of Sub-Saharan Africa (developing only) and Population (in %) of Georgia?
Your response must be concise. -12.69. In the year 1998, what is the difference between the Population (in %) in Sub-Saharan Africa (developing only) and Population (in %) in West Bank and Gaza?
Give a very brief answer. 2.89. In the year 1998, what is the difference between the Population (in %) in Georgia and Population (in %) in West Bank and Gaza?
Your answer should be compact. 15.58. In the year 1999, what is the difference between the Population (in %) of Small states and Population (in %) of Sub-Saharan Africa (developing only)?
Ensure brevity in your answer.  4.71. In the year 1999, what is the difference between the Population (in %) of Small states and Population (in %) of Georgia?
Keep it short and to the point. -8.14. In the year 1999, what is the difference between the Population (in %) of Small states and Population (in %) of West Bank and Gaza?
Provide a succinct answer. 7.53. In the year 1999, what is the difference between the Population (in %) of Sub-Saharan Africa (developing only) and Population (in %) of Georgia?
Provide a succinct answer. -12.86. In the year 1999, what is the difference between the Population (in %) of Sub-Saharan Africa (developing only) and Population (in %) of West Bank and Gaza?
Ensure brevity in your answer.  2.81. In the year 1999, what is the difference between the Population (in %) of Georgia and Population (in %) of West Bank and Gaza?
Provide a succinct answer. 15.67. In the year 2000, what is the difference between the Population (in %) in Small states and Population (in %) in Sub-Saharan Africa (developing only)?
Offer a very short reply. 4.84. In the year 2000, what is the difference between the Population (in %) of Small states and Population (in %) of Georgia?
Offer a terse response. -8.16. In the year 2000, what is the difference between the Population (in %) in Small states and Population (in %) in West Bank and Gaza?
Your response must be concise. 7.52. In the year 2000, what is the difference between the Population (in %) in Sub-Saharan Africa (developing only) and Population (in %) in Georgia?
Your response must be concise. -13. In the year 2000, what is the difference between the Population (in %) of Sub-Saharan Africa (developing only) and Population (in %) of West Bank and Gaza?
Keep it short and to the point. 2.68. In the year 2000, what is the difference between the Population (in %) of Georgia and Population (in %) of West Bank and Gaza?
Make the answer very short. 15.68. In the year 2001, what is the difference between the Population (in %) in Small states and Population (in %) in Sub-Saharan Africa (developing only)?
Ensure brevity in your answer.  5.16. In the year 2001, what is the difference between the Population (in %) in Small states and Population (in %) in Georgia?
Your answer should be very brief. -8.05. In the year 2001, what is the difference between the Population (in %) in Small states and Population (in %) in West Bank and Gaza?
Your answer should be compact. 7.52. In the year 2001, what is the difference between the Population (in %) in Sub-Saharan Africa (developing only) and Population (in %) in Georgia?
Provide a succinct answer. -13.21. In the year 2001, what is the difference between the Population (in %) in Sub-Saharan Africa (developing only) and Population (in %) in West Bank and Gaza?
Make the answer very short. 2.36. In the year 2001, what is the difference between the Population (in %) of Georgia and Population (in %) of West Bank and Gaza?
Give a very brief answer. 15.57. In the year 2002, what is the difference between the Population (in %) of Small states and Population (in %) of Sub-Saharan Africa (developing only)?
Ensure brevity in your answer.  5.44. In the year 2002, what is the difference between the Population (in %) of Small states and Population (in %) of Georgia?
Your answer should be very brief. -7.89. In the year 2002, what is the difference between the Population (in %) of Small states and Population (in %) of West Bank and Gaza?
Offer a terse response. 7.52. In the year 2002, what is the difference between the Population (in %) in Sub-Saharan Africa (developing only) and Population (in %) in Georgia?
Your response must be concise. -13.33. In the year 2002, what is the difference between the Population (in %) of Sub-Saharan Africa (developing only) and Population (in %) of West Bank and Gaza?
Offer a very short reply. 2.08. In the year 2002, what is the difference between the Population (in %) in Georgia and Population (in %) in West Bank and Gaza?
Make the answer very short. 15.41. In the year 2003, what is the difference between the Population (in %) of Small states and Population (in %) of Sub-Saharan Africa (developing only)?
Your answer should be compact. 5.7. In the year 2003, what is the difference between the Population (in %) of Small states and Population (in %) of Georgia?
Your response must be concise. -7.75. In the year 2003, what is the difference between the Population (in %) in Small states and Population (in %) in West Bank and Gaza?
Your answer should be compact. 7.49. In the year 2003, what is the difference between the Population (in %) of Sub-Saharan Africa (developing only) and Population (in %) of Georgia?
Your answer should be very brief. -13.45. In the year 2003, what is the difference between the Population (in %) of Sub-Saharan Africa (developing only) and Population (in %) of West Bank and Gaza?
Keep it short and to the point. 1.79. In the year 2003, what is the difference between the Population (in %) in Georgia and Population (in %) in West Bank and Gaza?
Provide a succinct answer. 15.24. In the year 2004, what is the difference between the Population (in %) in Small states and Population (in %) in Sub-Saharan Africa (developing only)?
Your answer should be very brief. 5.95. In the year 2004, what is the difference between the Population (in %) in Small states and Population (in %) in Georgia?
Provide a succinct answer. -7.75. In the year 2004, what is the difference between the Population (in %) in Small states and Population (in %) in West Bank and Gaza?
Ensure brevity in your answer.  7.39. In the year 2004, what is the difference between the Population (in %) of Sub-Saharan Africa (developing only) and Population (in %) of Georgia?
Provide a succinct answer. -13.7. In the year 2004, what is the difference between the Population (in %) in Sub-Saharan Africa (developing only) and Population (in %) in West Bank and Gaza?
Ensure brevity in your answer.  1.44. In the year 2004, what is the difference between the Population (in %) of Georgia and Population (in %) of West Bank and Gaza?
Provide a succinct answer. 15.14. In the year 2005, what is the difference between the Population (in %) of Small states and Population (in %) of Sub-Saharan Africa (developing only)?
Make the answer very short. 6.21. In the year 2005, what is the difference between the Population (in %) of Small states and Population (in %) of Georgia?
Give a very brief answer. -7.92. In the year 2005, what is the difference between the Population (in %) in Small states and Population (in %) in West Bank and Gaza?
Provide a succinct answer. 7.24. In the year 2005, what is the difference between the Population (in %) in Sub-Saharan Africa (developing only) and Population (in %) in Georgia?
Give a very brief answer. -14.13. In the year 2005, what is the difference between the Population (in %) of Sub-Saharan Africa (developing only) and Population (in %) of West Bank and Gaza?
Your answer should be compact. 1.03. In the year 2005, what is the difference between the Population (in %) of Georgia and Population (in %) of West Bank and Gaza?
Offer a very short reply. 15.16. What is the ratio of the Population (in %) of Small states in 1998 to that in 1999?
Provide a succinct answer. 1. What is the ratio of the Population (in %) in Sub-Saharan Africa (developing only) in 1998 to that in 1999?
Keep it short and to the point. 1. What is the ratio of the Population (in %) of Georgia in 1998 to that in 1999?
Your answer should be very brief. 1. What is the ratio of the Population (in %) of Small states in 1998 to that in 2000?
Offer a very short reply. 0.99. What is the ratio of the Population (in %) of Small states in 1998 to that in 2001?
Give a very brief answer. 0.99. What is the ratio of the Population (in %) in Georgia in 1998 to that in 2001?
Your answer should be compact. 0.99. What is the ratio of the Population (in %) of West Bank and Gaza in 1998 to that in 2001?
Your answer should be very brief. 0.98. What is the ratio of the Population (in %) of Small states in 1998 to that in 2002?
Give a very brief answer. 0.98. What is the ratio of the Population (in %) of Georgia in 1998 to that in 2002?
Offer a terse response. 0.99. What is the ratio of the Population (in %) of West Bank and Gaza in 1998 to that in 2002?
Offer a terse response. 0.98. What is the ratio of the Population (in %) in Small states in 1998 to that in 2003?
Provide a succinct answer. 0.97. What is the ratio of the Population (in %) in Georgia in 1998 to that in 2003?
Ensure brevity in your answer.  0.98. What is the ratio of the Population (in %) of West Bank and Gaza in 1998 to that in 2003?
Offer a very short reply. 0.97. What is the ratio of the Population (in %) in Small states in 1998 to that in 2004?
Ensure brevity in your answer.  0.97. What is the ratio of the Population (in %) in Sub-Saharan Africa (developing only) in 1998 to that in 2004?
Your answer should be very brief. 0.99. What is the ratio of the Population (in %) in Georgia in 1998 to that in 2004?
Give a very brief answer. 0.98. What is the ratio of the Population (in %) in West Bank and Gaza in 1998 to that in 2004?
Provide a short and direct response. 0.96. What is the ratio of the Population (in %) in Small states in 1998 to that in 2005?
Your answer should be compact. 0.96. What is the ratio of the Population (in %) in Sub-Saharan Africa (developing only) in 1998 to that in 2005?
Offer a terse response. 0.99. What is the ratio of the Population (in %) of Georgia in 1998 to that in 2005?
Offer a terse response. 0.97. What is the ratio of the Population (in %) in West Bank and Gaza in 1998 to that in 2005?
Give a very brief answer. 0.95. What is the ratio of the Population (in %) in Small states in 1999 to that in 2000?
Provide a short and direct response. 1. What is the ratio of the Population (in %) in Sub-Saharan Africa (developing only) in 1999 to that in 2000?
Offer a very short reply. 1. What is the ratio of the Population (in %) in Georgia in 1999 to that in 2000?
Give a very brief answer. 1. What is the ratio of the Population (in %) in Georgia in 1999 to that in 2001?
Provide a short and direct response. 0.99. What is the ratio of the Population (in %) of Small states in 1999 to that in 2002?
Make the answer very short. 0.98. What is the ratio of the Population (in %) in Sub-Saharan Africa (developing only) in 1999 to that in 2002?
Give a very brief answer. 1. What is the ratio of the Population (in %) of Georgia in 1999 to that in 2002?
Your answer should be very brief. 0.99. What is the ratio of the Population (in %) in West Bank and Gaza in 1999 to that in 2002?
Keep it short and to the point. 0.98. What is the ratio of the Population (in %) of Small states in 1999 to that in 2003?
Offer a terse response. 0.98. What is the ratio of the Population (in %) in Sub-Saharan Africa (developing only) in 1999 to that in 2003?
Make the answer very short. 0.99. What is the ratio of the Population (in %) of West Bank and Gaza in 1999 to that in 2003?
Provide a succinct answer. 0.97. What is the ratio of the Population (in %) of Small states in 1999 to that in 2004?
Ensure brevity in your answer.  0.97. What is the ratio of the Population (in %) in Georgia in 1999 to that in 2004?
Your response must be concise. 0.98. What is the ratio of the Population (in %) in West Bank and Gaza in 1999 to that in 2004?
Offer a very short reply. 0.97. What is the ratio of the Population (in %) in Small states in 1999 to that in 2005?
Ensure brevity in your answer.  0.97. What is the ratio of the Population (in %) of Sub-Saharan Africa (developing only) in 1999 to that in 2005?
Provide a short and direct response. 0.99. What is the ratio of the Population (in %) in Georgia in 1999 to that in 2005?
Offer a terse response. 0.97. What is the ratio of the Population (in %) in West Bank and Gaza in 1999 to that in 2005?
Offer a very short reply. 0.96. What is the ratio of the Population (in %) of Small states in 2000 to that in 2001?
Your response must be concise. 0.99. What is the ratio of the Population (in %) of West Bank and Gaza in 2000 to that in 2001?
Offer a very short reply. 0.99. What is the ratio of the Population (in %) in Small states in 2000 to that in 2002?
Your answer should be very brief. 0.99. What is the ratio of the Population (in %) in Sub-Saharan Africa (developing only) in 2000 to that in 2002?
Provide a succinct answer. 1. What is the ratio of the Population (in %) in West Bank and Gaza in 2000 to that in 2002?
Provide a succinct answer. 0.99. What is the ratio of the Population (in %) of Small states in 2000 to that in 2003?
Provide a short and direct response. 0.98. What is the ratio of the Population (in %) of West Bank and Gaza in 2000 to that in 2003?
Your response must be concise. 0.98. What is the ratio of the Population (in %) in Georgia in 2000 to that in 2004?
Give a very brief answer. 0.99. What is the ratio of the Population (in %) in West Bank and Gaza in 2000 to that in 2004?
Make the answer very short. 0.97. What is the ratio of the Population (in %) in Small states in 2000 to that in 2005?
Give a very brief answer. 0.97. What is the ratio of the Population (in %) in Sub-Saharan Africa (developing only) in 2000 to that in 2005?
Offer a very short reply. 0.99. What is the ratio of the Population (in %) of Georgia in 2000 to that in 2005?
Ensure brevity in your answer.  0.98. What is the ratio of the Population (in %) in West Bank and Gaza in 2000 to that in 2005?
Provide a short and direct response. 0.96. What is the ratio of the Population (in %) in Small states in 2001 to that in 2003?
Keep it short and to the point. 0.99. What is the ratio of the Population (in %) of Sub-Saharan Africa (developing only) in 2001 to that in 2003?
Provide a short and direct response. 1. What is the ratio of the Population (in %) in Georgia in 2001 to that in 2003?
Give a very brief answer. 0.99. What is the ratio of the Population (in %) of West Bank and Gaza in 2001 to that in 2003?
Make the answer very short. 0.99. What is the ratio of the Population (in %) in Small states in 2001 to that in 2004?
Provide a short and direct response. 0.98. What is the ratio of the Population (in %) in Sub-Saharan Africa (developing only) in 2001 to that in 2004?
Provide a succinct answer. 1. What is the ratio of the Population (in %) of Georgia in 2001 to that in 2004?
Your response must be concise. 0.99. What is the ratio of the Population (in %) in West Bank and Gaza in 2001 to that in 2004?
Offer a terse response. 0.98. What is the ratio of the Population (in %) of Small states in 2001 to that in 2005?
Provide a succinct answer. 0.98. What is the ratio of the Population (in %) of Georgia in 2001 to that in 2005?
Give a very brief answer. 0.98. What is the ratio of the Population (in %) of West Bank and Gaza in 2001 to that in 2005?
Provide a succinct answer. 0.97. What is the ratio of the Population (in %) of Sub-Saharan Africa (developing only) in 2002 to that in 2003?
Give a very brief answer. 1. What is the ratio of the Population (in %) in West Bank and Gaza in 2002 to that in 2003?
Give a very brief answer. 0.99. What is the ratio of the Population (in %) in Small states in 2002 to that in 2004?
Your answer should be very brief. 0.99. What is the ratio of the Population (in %) of Sub-Saharan Africa (developing only) in 2002 to that in 2004?
Ensure brevity in your answer.  1. What is the ratio of the Population (in %) in West Bank and Gaza in 2002 to that in 2004?
Give a very brief answer. 0.98. What is the ratio of the Population (in %) of Small states in 2002 to that in 2005?
Keep it short and to the point. 0.98. What is the ratio of the Population (in %) in Georgia in 2002 to that in 2005?
Ensure brevity in your answer.  0.98. What is the ratio of the Population (in %) in West Bank and Gaza in 2002 to that in 2005?
Offer a very short reply. 0.97. What is the ratio of the Population (in %) in Small states in 2003 to that in 2004?
Your response must be concise. 0.99. What is the ratio of the Population (in %) in West Bank and Gaza in 2003 to that in 2004?
Provide a short and direct response. 0.99. What is the ratio of the Population (in %) in Georgia in 2003 to that in 2005?
Offer a terse response. 0.99. What is the ratio of the Population (in %) in West Bank and Gaza in 2003 to that in 2005?
Your answer should be very brief. 0.98. What is the ratio of the Population (in %) in Small states in 2004 to that in 2005?
Your answer should be very brief. 0.99. What is the ratio of the Population (in %) of Georgia in 2004 to that in 2005?
Keep it short and to the point. 0.99. What is the ratio of the Population (in %) of West Bank and Gaza in 2004 to that in 2005?
Your answer should be compact. 0.99. What is the difference between the highest and the second highest Population (in %) in Small states?
Your answer should be very brief. 0.37. What is the difference between the highest and the second highest Population (in %) in Sub-Saharan Africa (developing only)?
Keep it short and to the point. 0.11. What is the difference between the highest and the second highest Population (in %) of Georgia?
Provide a short and direct response. 0.53. What is the difference between the highest and the second highest Population (in %) of West Bank and Gaza?
Ensure brevity in your answer.  0.52. What is the difference between the highest and the lowest Population (in %) of Small states?
Make the answer very short. 2.23. What is the difference between the highest and the lowest Population (in %) of Sub-Saharan Africa (developing only)?
Provide a succinct answer. 0.59. What is the difference between the highest and the lowest Population (in %) of Georgia?
Your answer should be compact. 2.04. What is the difference between the highest and the lowest Population (in %) in West Bank and Gaza?
Make the answer very short. 2.46. 